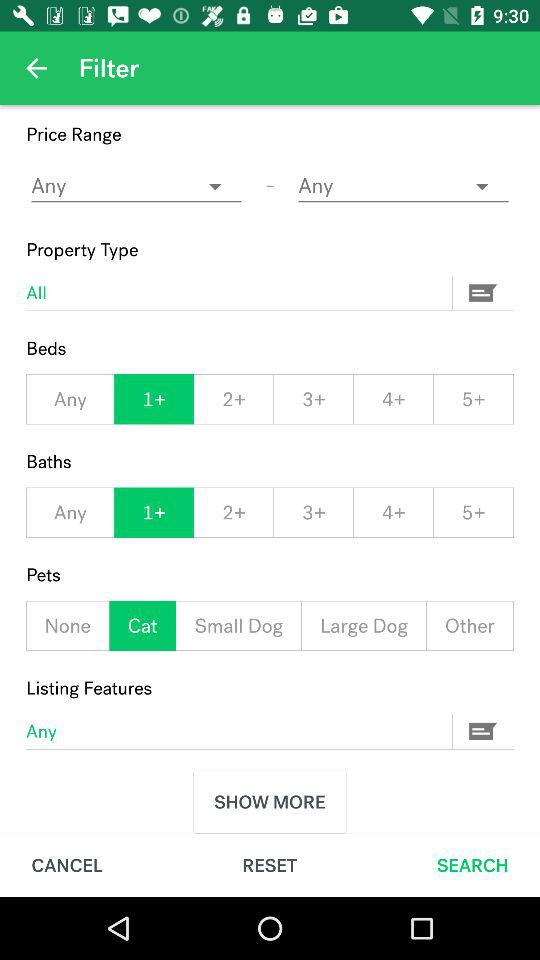What is the selected number of beds? The selected number of beds is more than 1. 